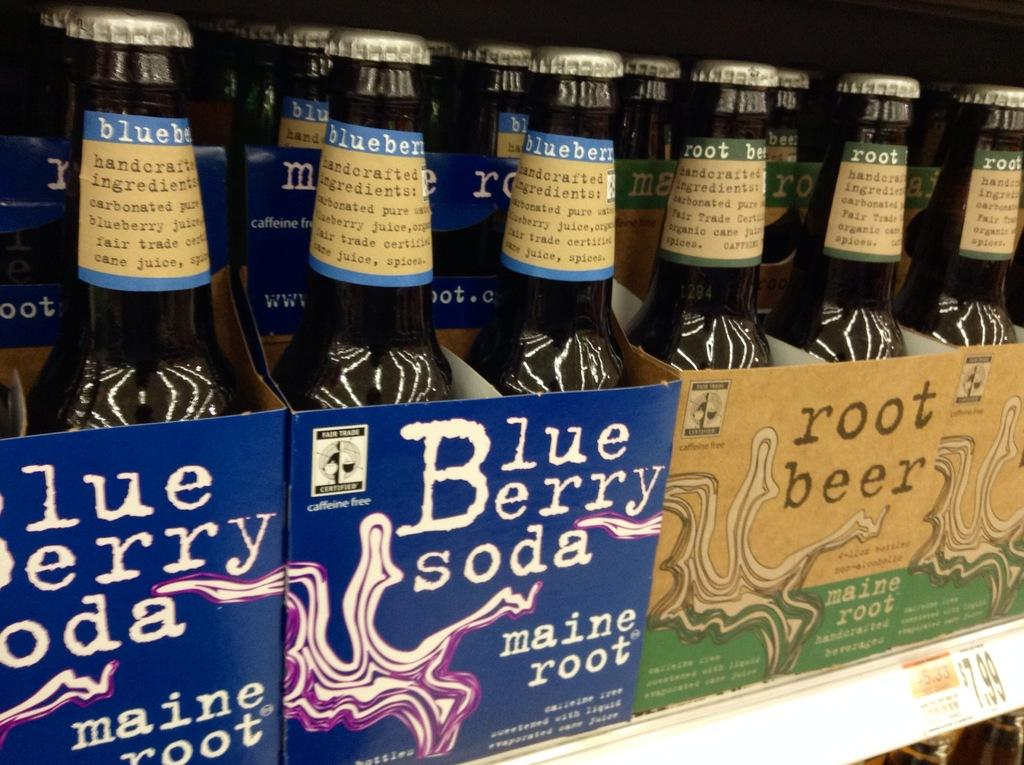Provide a one-sentence caption for the provided image. Maine Root blueberry soda and root beer on a store shelf. 